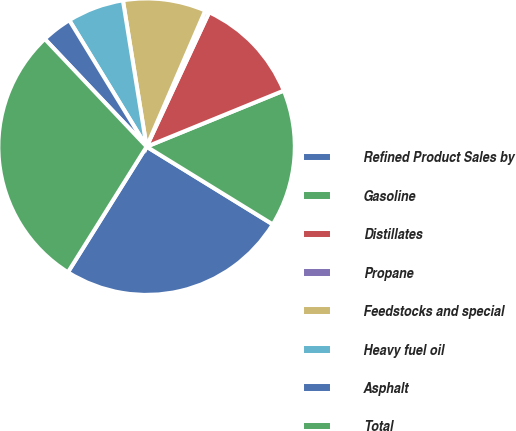Convert chart to OTSL. <chart><loc_0><loc_0><loc_500><loc_500><pie_chart><fcel>Refined Product Sales by<fcel>Gasoline<fcel>Distillates<fcel>Propane<fcel>Feedstocks and special<fcel>Heavy fuel oil<fcel>Asphalt<fcel>Total<nl><fcel>25.12%<fcel>14.96%<fcel>11.89%<fcel>0.46%<fcel>9.03%<fcel>6.18%<fcel>3.32%<fcel>29.04%<nl></chart> 